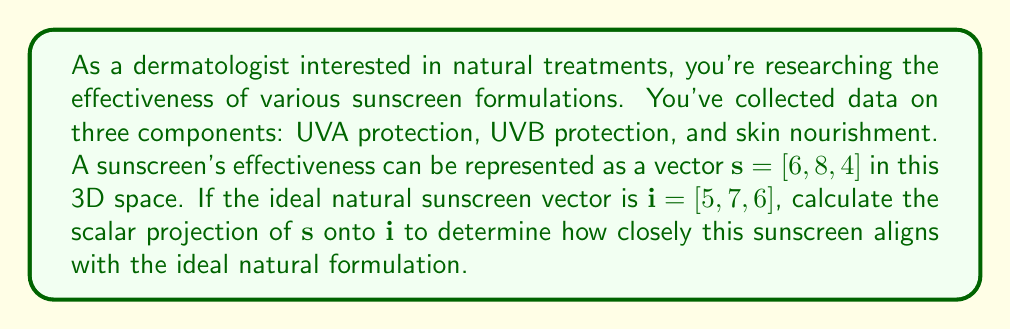What is the answer to this math problem? To solve this problem, we'll use vector projection. The scalar projection of $\mathbf{s}$ onto $\mathbf{i}$ is given by the formula:

$$\text{proj}_{\mathbf{i}}\mathbf{s} = \frac{\mathbf{s} \cdot \mathbf{i}}{\|\mathbf{i}\|}$$

Let's break this down step-by-step:

1) First, calculate the dot product $\mathbf{s} \cdot \mathbf{i}$:
   $$\mathbf{s} \cdot \mathbf{i} = (6)(5) + (8)(7) + (4)(6) = 30 + 56 + 24 = 110$$

2) Next, calculate the magnitude of $\mathbf{i}$:
   $$\|\mathbf{i}\| = \sqrt{5^2 + 7^2 + 6^2} = \sqrt{25 + 49 + 36} = \sqrt{110}$$

3) Now, we can substitute these values into our projection formula:
   $$\text{proj}_{\mathbf{i}}\mathbf{s} = \frac{110}{\sqrt{110}}$$

4) Simplify:
   $$\text{proj}_{\mathbf{i}}\mathbf{s} = \sqrt{110} \approx 10.488$$

This scalar value represents how closely the sunscreen aligns with the ideal natural formulation in terms of magnitude along the ideal vector's direction.
Answer: The scalar projection of $\mathbf{s}$ onto $\mathbf{i}$ is $\sqrt{110} \approx 10.488$. 